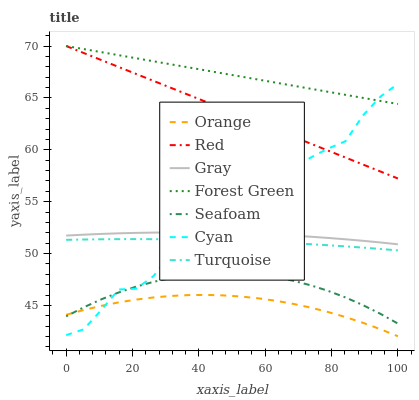Does Orange have the minimum area under the curve?
Answer yes or no. Yes. Does Forest Green have the maximum area under the curve?
Answer yes or no. Yes. Does Turquoise have the minimum area under the curve?
Answer yes or no. No. Does Turquoise have the maximum area under the curve?
Answer yes or no. No. Is Forest Green the smoothest?
Answer yes or no. Yes. Is Cyan the roughest?
Answer yes or no. Yes. Is Turquoise the smoothest?
Answer yes or no. No. Is Turquoise the roughest?
Answer yes or no. No. Does Turquoise have the lowest value?
Answer yes or no. No. Does Red have the highest value?
Answer yes or no. Yes. Does Turquoise have the highest value?
Answer yes or no. No. Is Turquoise less than Forest Green?
Answer yes or no. Yes. Is Forest Green greater than Gray?
Answer yes or no. Yes. Does Seafoam intersect Cyan?
Answer yes or no. Yes. Is Seafoam less than Cyan?
Answer yes or no. No. Is Seafoam greater than Cyan?
Answer yes or no. No. Does Turquoise intersect Forest Green?
Answer yes or no. No. 